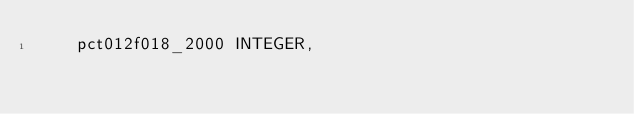Convert code to text. <code><loc_0><loc_0><loc_500><loc_500><_SQL_>	pct012f018_2000 INTEGER, </code> 